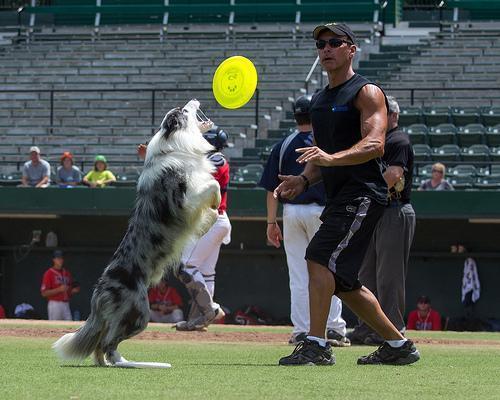How many dogs are there?
Give a very brief answer. 1. 